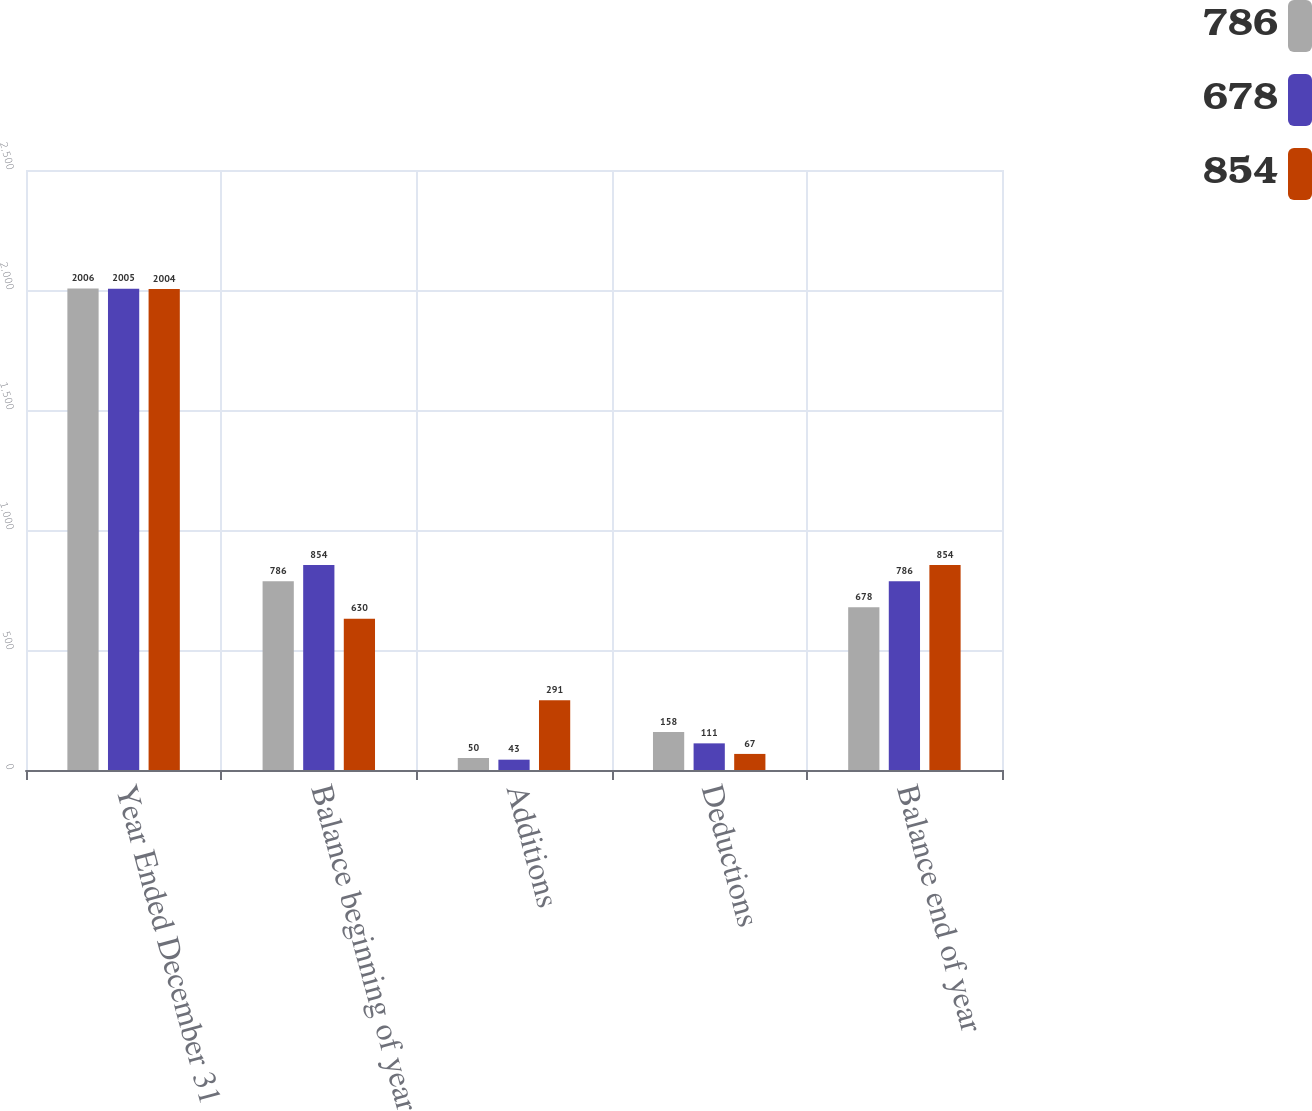<chart> <loc_0><loc_0><loc_500><loc_500><stacked_bar_chart><ecel><fcel>Year Ended December 31<fcel>Balance beginning of year<fcel>Additions<fcel>Deductions<fcel>Balance end of year<nl><fcel>786<fcel>2006<fcel>786<fcel>50<fcel>158<fcel>678<nl><fcel>678<fcel>2005<fcel>854<fcel>43<fcel>111<fcel>786<nl><fcel>854<fcel>2004<fcel>630<fcel>291<fcel>67<fcel>854<nl></chart> 